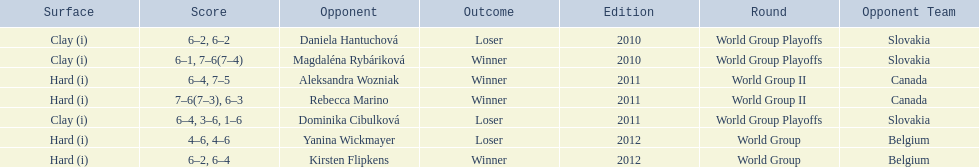Was the game versus canada later than the game versus belgium? No. 